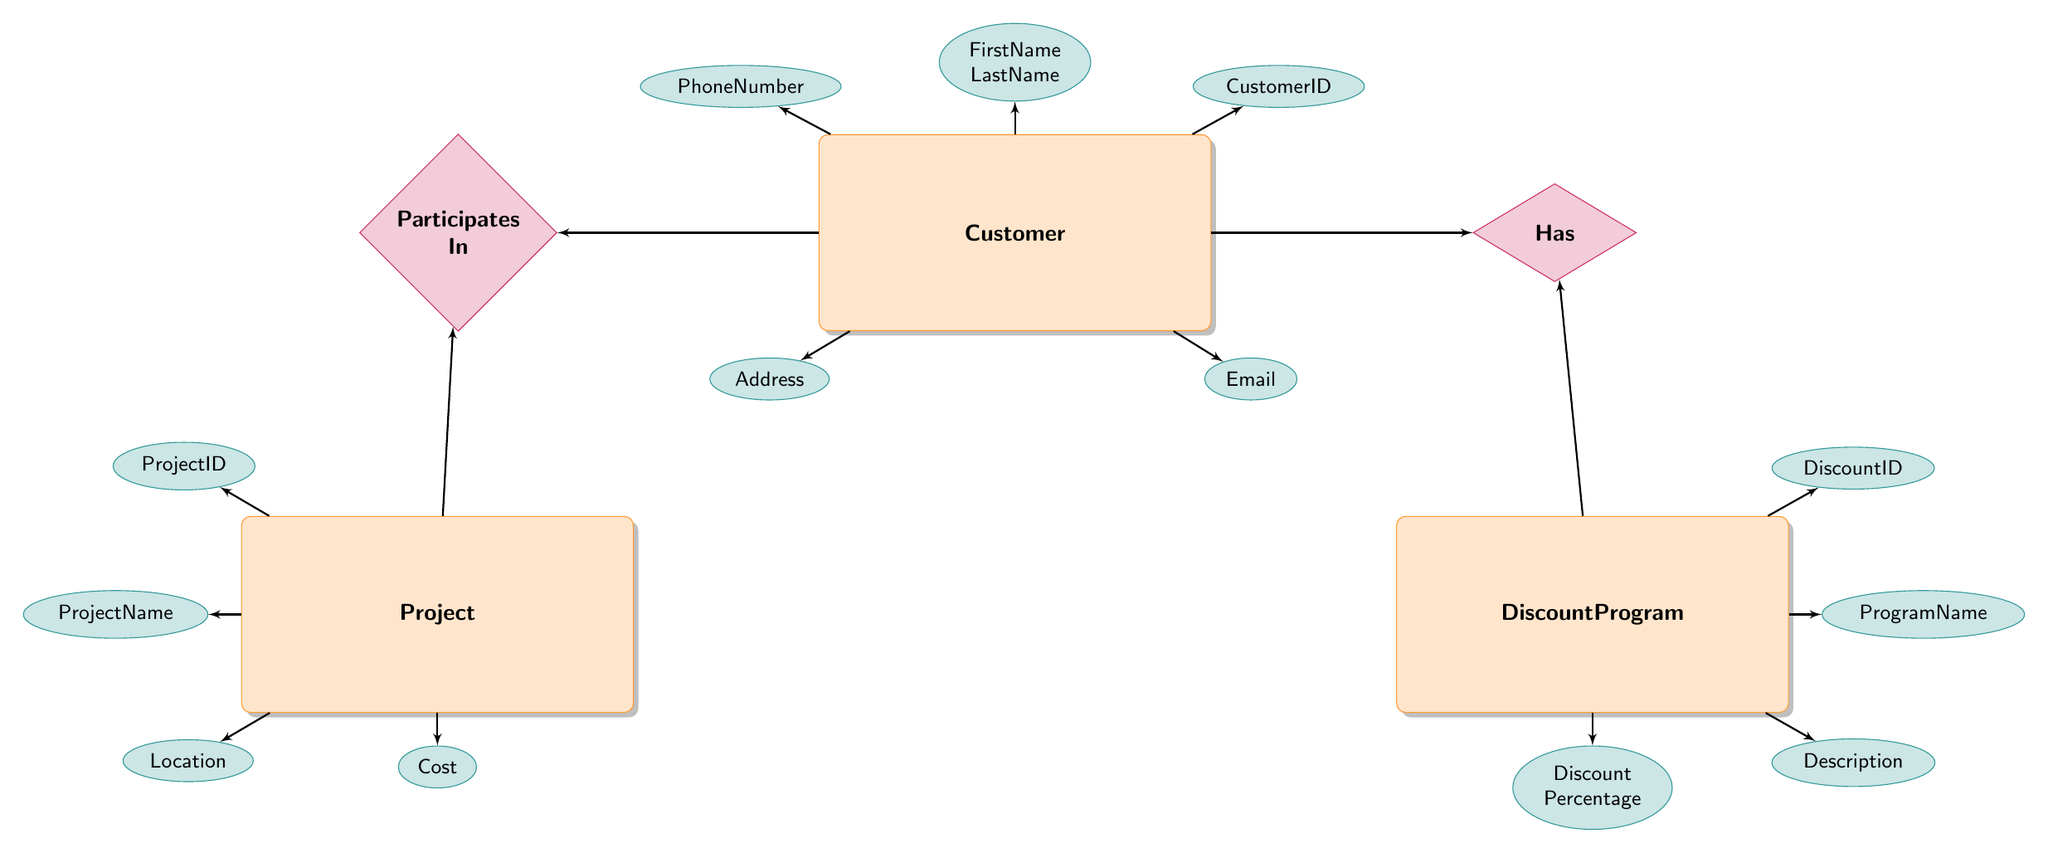What is the primary key of the Customer entity? The primary key is listed directly in the diagram, indicating the unique identifier for each Customer. It is specified as CustomerID.
Answer: CustomerID How many attributes does the DiscountProgram entity have? By looking at the attributes listed for DiscountProgram in the diagram, I can count that it has five attributes: DiscountID, ProgramName, Description, DiscountPercentage, StartDate, and EndDate.
Answer: Five What relationship exists between Customer and DiscountProgram? The diagram shows a relationship labeled "Has" connecting the Customer entity to the DiscountProgram entity. This indicates that customers can be associated with certain discount programs.
Answer: Has What attributes belong to the Project entity? The diagram lists four attributes under the Project entity: ProjectID, ProjectName, Location, and Cost. These attributes describe the project itself.
Answer: ProjectID, ProjectName, Location, Cost Which entity has a composite primary key? The diagram indicates that the CustomerProject and CustomerDiscount entities have composite primary keys, which consist of two foreign keys from other entities: CustomerID and ProjectID in CustomerProject; CustomerID and DiscountID in CustomerDiscount.
Answer: CustomerProject, CustomerDiscount How does a Customer participate in a Project? The diagram shows a relationship labeled "Participates In," indicating that there is a connection between the Customer and Project entities. This relationship denotes that customers can take part in specific projects.
Answer: Participates In How many foreign keys are present in the CustomerProject entity? The diagram shows that the CustomerProject entity has two foreign keys: CustomerID and ProjectID, which link it to the respective Customer and Project entities.
Answer: Two Which entity describes the discounts available to customers? The diagram denotes the DiscountProgram entity as the one that describes available discounts, providing information on discount types, percentages, and their validity periods.
Answer: DiscountProgram What is the purpose of the CustomerDiscount entity? The CustomerDiscount entity tracks which discounts have been applied to which customers and records the date of application. This is evident from its attributes and the relationship it has with both Customer and DiscountProgram entities.
Answer: Track discounts applied to customers 